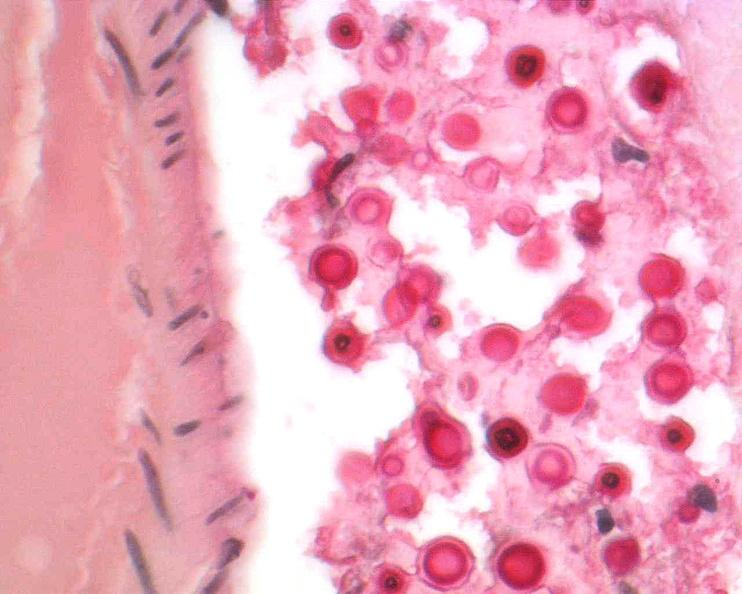s nervous present?
Answer the question using a single word or phrase. Yes 